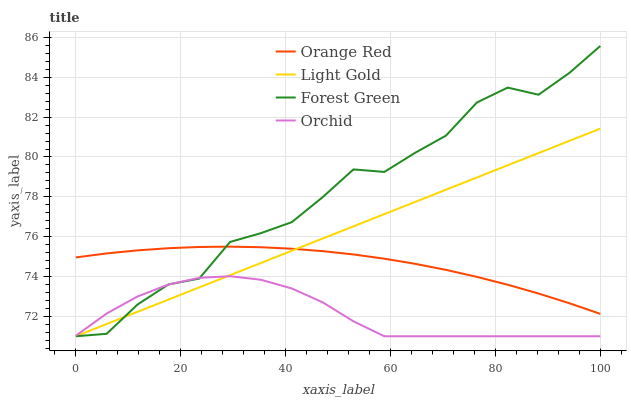Does Orchid have the minimum area under the curve?
Answer yes or no. Yes. Does Forest Green have the maximum area under the curve?
Answer yes or no. Yes. Does Light Gold have the minimum area under the curve?
Answer yes or no. No. Does Light Gold have the maximum area under the curve?
Answer yes or no. No. Is Light Gold the smoothest?
Answer yes or no. Yes. Is Forest Green the roughest?
Answer yes or no. Yes. Is Orange Red the smoothest?
Answer yes or no. No. Is Orange Red the roughest?
Answer yes or no. No. Does Forest Green have the lowest value?
Answer yes or no. Yes. Does Orange Red have the lowest value?
Answer yes or no. No. Does Forest Green have the highest value?
Answer yes or no. Yes. Does Light Gold have the highest value?
Answer yes or no. No. Is Orchid less than Orange Red?
Answer yes or no. Yes. Is Orange Red greater than Orchid?
Answer yes or no. Yes. Does Light Gold intersect Orange Red?
Answer yes or no. Yes. Is Light Gold less than Orange Red?
Answer yes or no. No. Is Light Gold greater than Orange Red?
Answer yes or no. No. Does Orchid intersect Orange Red?
Answer yes or no. No. 